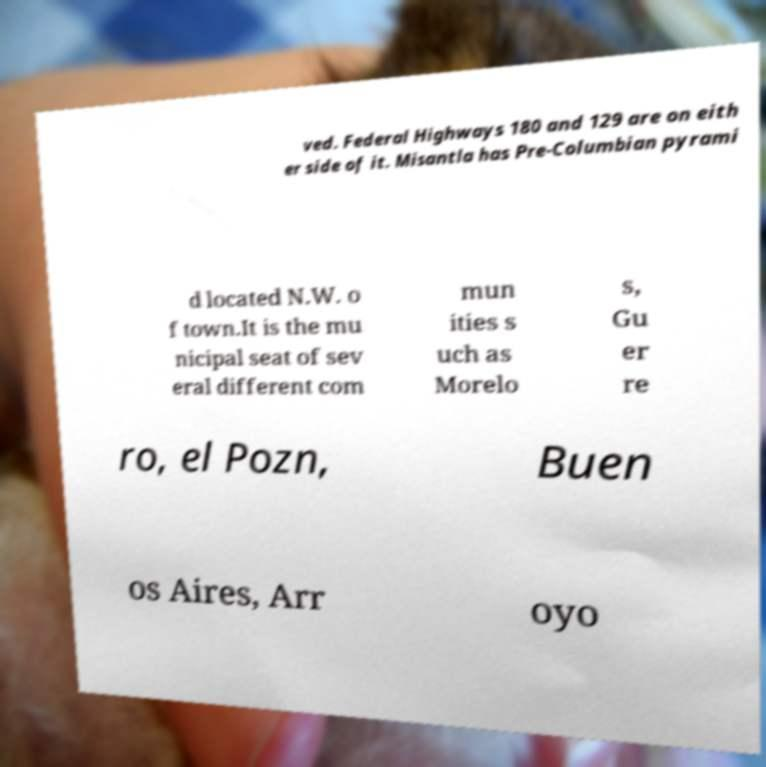Please identify and transcribe the text found in this image. ved. Federal Highways 180 and 129 are on eith er side of it. Misantla has Pre-Columbian pyrami d located N.W. o f town.It is the mu nicipal seat of sev eral different com mun ities s uch as Morelo s, Gu er re ro, el Pozn, Buen os Aires, Arr oyo 